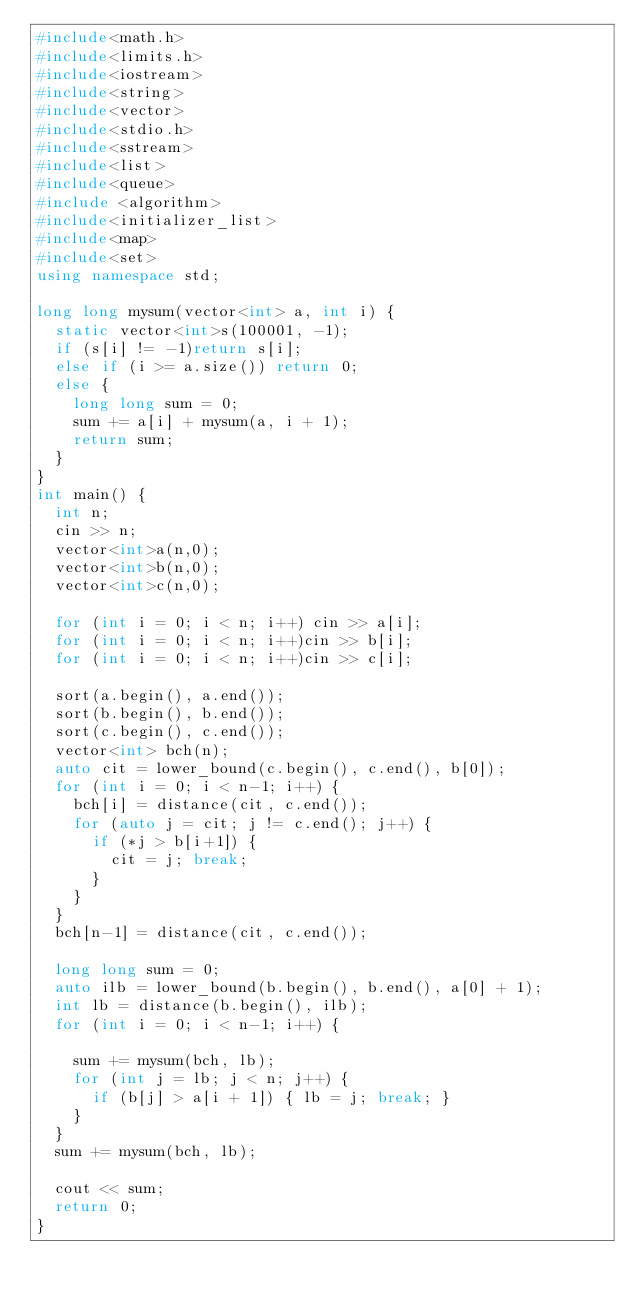<code> <loc_0><loc_0><loc_500><loc_500><_C++_>#include<math.h>
#include<limits.h>
#include<iostream>
#include<string>
#include<vector>
#include<stdio.h>
#include<sstream>
#include<list>
#include<queue>
#include <algorithm>
#include<initializer_list>
#include<map>
#include<set>
using namespace std;

long long mysum(vector<int> a, int i) {
	static vector<int>s(100001, -1);
	if (s[i] != -1)return s[i];
	else if (i >= a.size()) return 0;
	else {
		long long sum = 0;
		sum += a[i] + mysum(a, i + 1);
		return sum;
	}
}
int main() {
	int n;
	cin >> n;
	vector<int>a(n,0);
	vector<int>b(n,0);
	vector<int>c(n,0);

	for (int i = 0; i < n; i++) cin >> a[i];
	for (int i = 0; i < n; i++)cin >> b[i];
	for (int i = 0; i < n; i++)cin >> c[i];
	
	sort(a.begin(), a.end());
	sort(b.begin(), b.end());
	sort(c.begin(), c.end());
	vector<int> bch(n);
	auto cit = lower_bound(c.begin(), c.end(), b[0]);
	for (int i = 0; i < n-1; i++) {
		bch[i] = distance(cit, c.end());
		for (auto j = cit; j != c.end(); j++) {
			if (*j > b[i+1]) {
				cit = j; break;
			}
		}
	}
	bch[n-1] = distance(cit, c.end());
	
	long long sum = 0;
	auto ilb = lower_bound(b.begin(), b.end(), a[0] + 1);
	int lb = distance(b.begin(), ilb);
	for (int i = 0; i < n-1; i++) {
		
		sum += mysum(bch, lb);
		for (int j = lb; j < n; j++) {
			if (b[j] > a[i + 1]) { lb = j; break; }
		}
	}
	sum += mysum(bch, lb);

	cout << sum;
	return 0;
}



</code> 